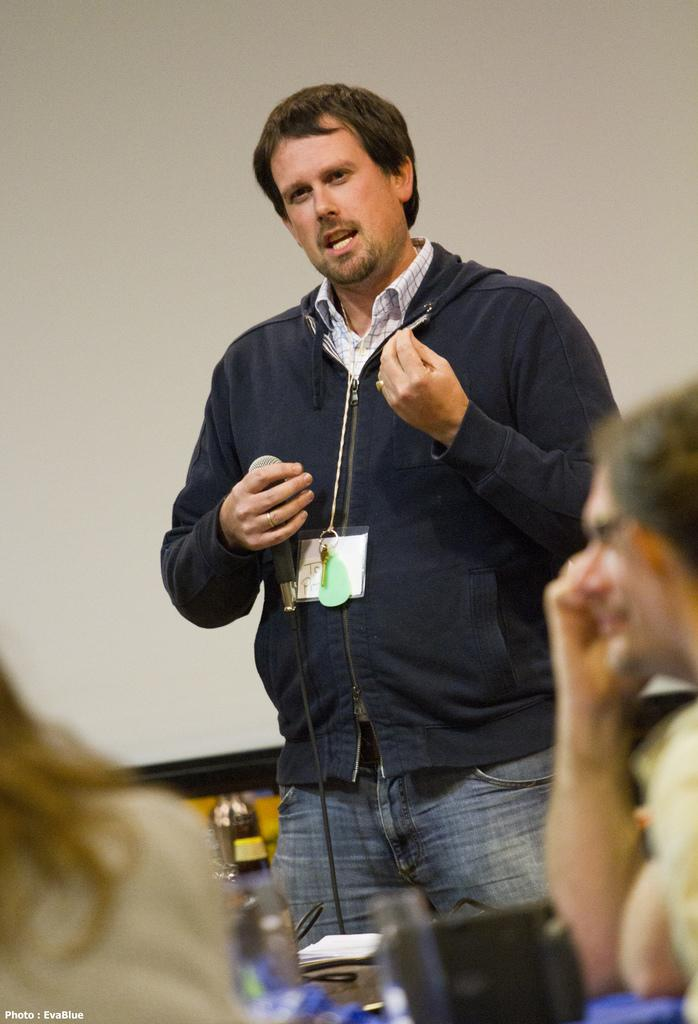What is the person in the image doing? The person is standing and talking. What is the person holding while talking? The person is holding a microphone. How many people are sitting in the image? There are two persons sitting in the image. What can be seen on the table in the image? There is a table with objects on it. What type of cabbage is being served on the table in the image? There is no cabbage present in the image; it only shows a person standing and talking, holding a microphone, and two persons sitting near a table with objects on it. 